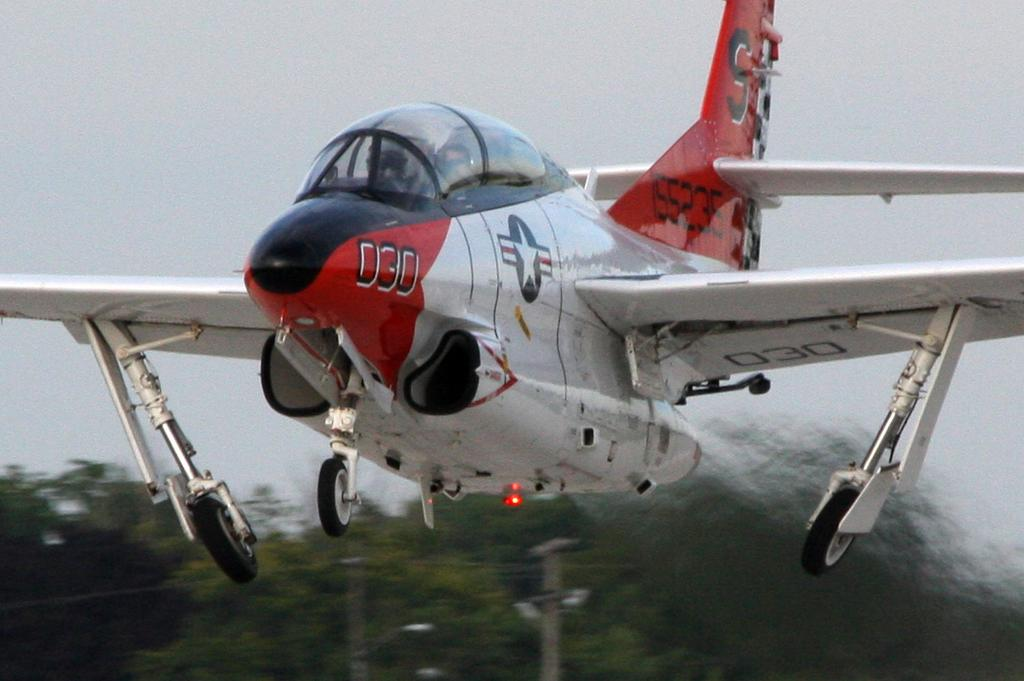Provide a one-sentence caption for the provided image. An airplane with the number 030 on the side and an S on the fin. 